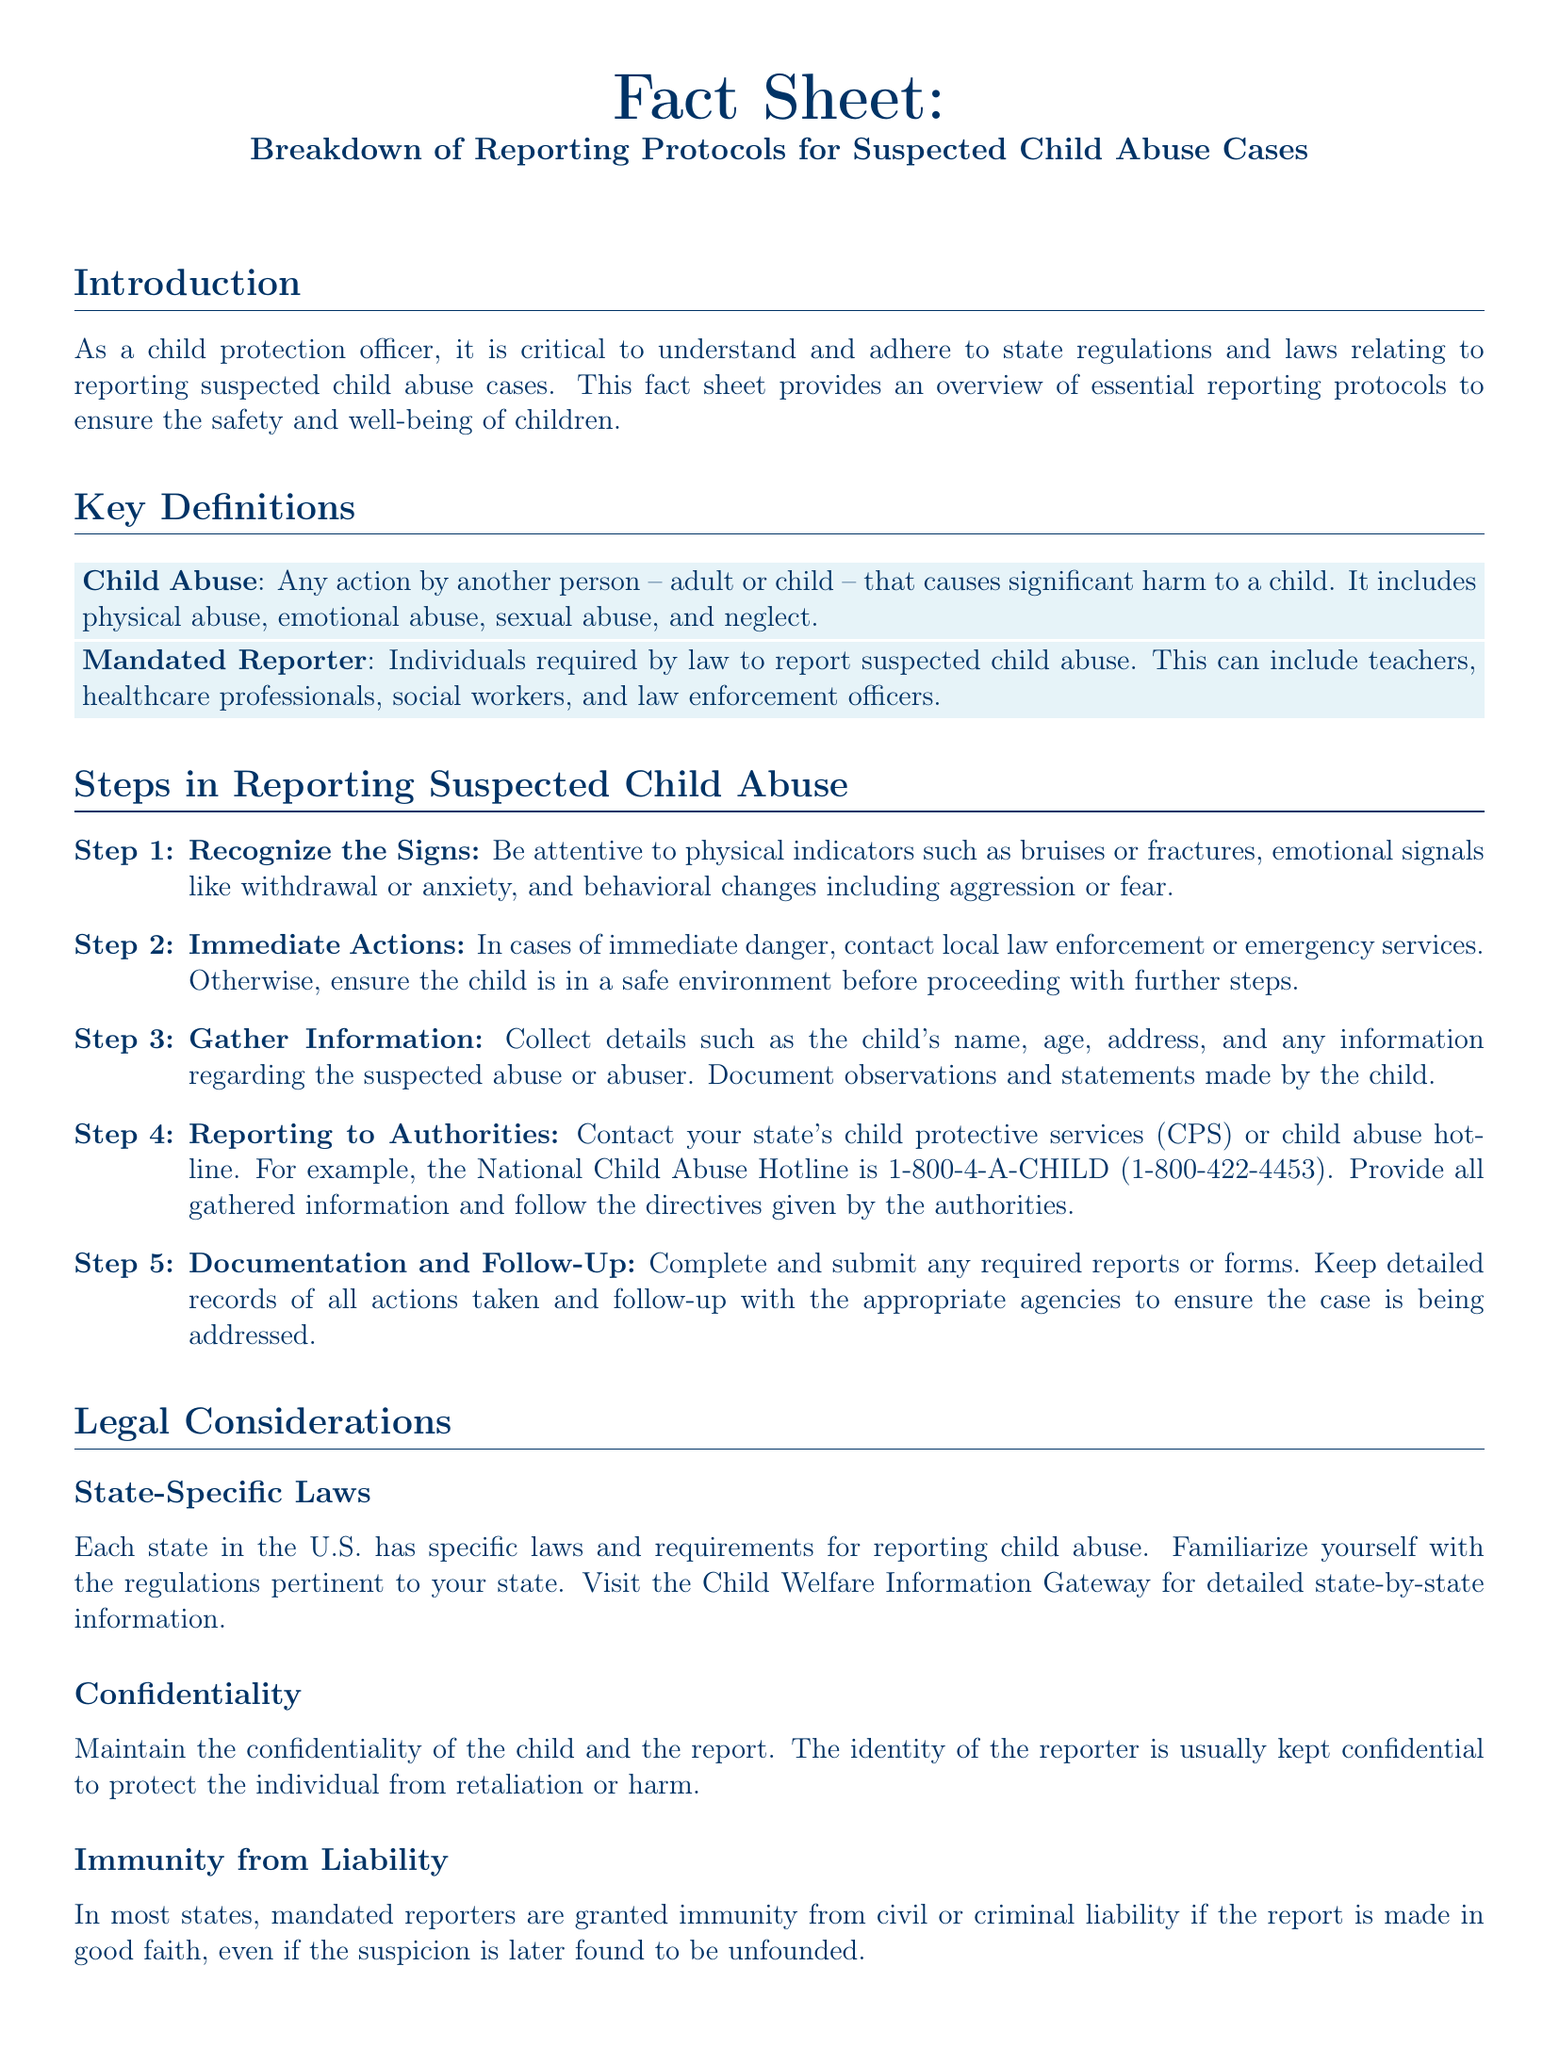What is the definition of child abuse? Child abuse is defined as any action by another person that causes significant harm to a child and includes physical abuse, emotional abuse, sexual abuse, and neglect.
Answer: Any action by another person that causes significant harm to a child Who are mandated reporters? Mandated reporters are individuals required by law to report suspected child abuse, which can include teachers, healthcare professionals, social workers, and law enforcement officers.
Answer: Individuals required by law to report suspected child abuse What should be done in cases of immediate danger? In cases of immediate danger, it is important to contact local law enforcement or emergency services.
Answer: Contact local law enforcement or emergency services What is the National Child Abuse Hotline number? The National Child Abuse Hotline number provided in the document is 1-800-4-A-CHILD.
Answer: 1-800-4-A-CHILD What is the purpose of maintaining confidentiality? The purpose of maintaining confidentiality is to protect the identity of the reporter and the child from retaliation or harm.
Answer: Protect the identity of the reporter What should be done after gathering information? After gathering information, the next step is to report to the authorities, such as contacting the state’s child protective services or the child abuse hotline.
Answer: Report to authorities What is the immunity granted to mandated reporters? Mandated reporters are granted immunity from civil or criminal liability if the report is made in good faith.
Answer: Immunity from civil or criminal liability Which organization provides detailed state-by-state information regarding child abuse laws? The Child Welfare Information Gateway provides detailed state-by-state information.
Answer: Child Welfare Information Gateway 